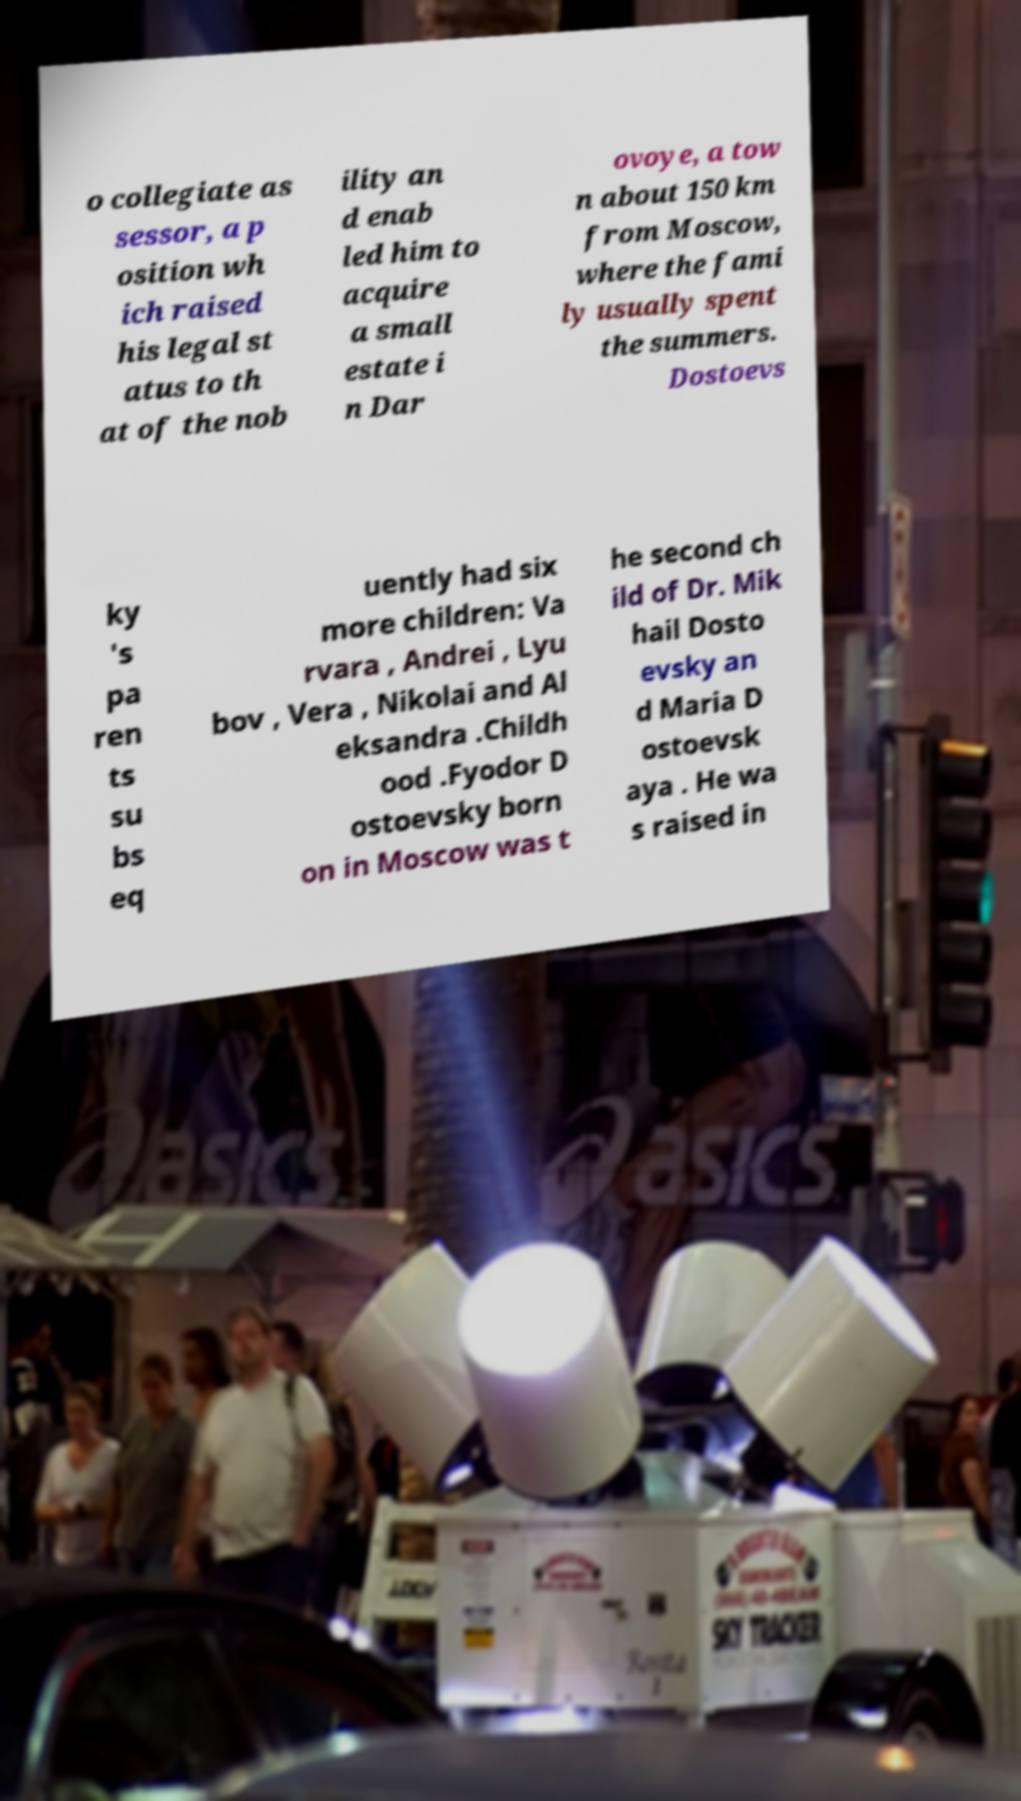Could you assist in decoding the text presented in this image and type it out clearly? o collegiate as sessor, a p osition wh ich raised his legal st atus to th at of the nob ility an d enab led him to acquire a small estate i n Dar ovoye, a tow n about 150 km from Moscow, where the fami ly usually spent the summers. Dostoevs ky 's pa ren ts su bs eq uently had six more children: Va rvara , Andrei , Lyu bov , Vera , Nikolai and Al eksandra .Childh ood .Fyodor D ostoevsky born on in Moscow was t he second ch ild of Dr. Mik hail Dosto evsky an d Maria D ostoevsk aya . He wa s raised in 